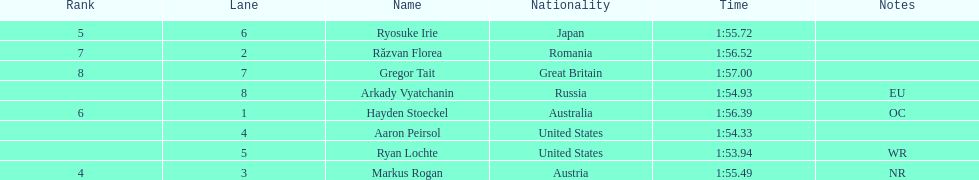How long did it take ryosuke irie to finish? 1:55.72. 